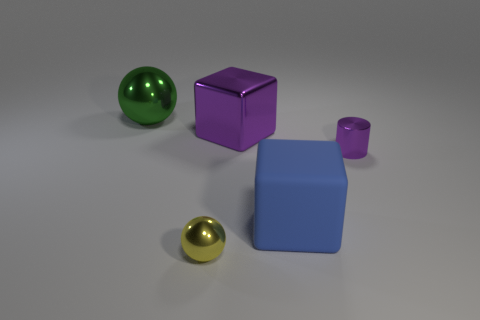What color is the other big thing that is the same shape as the yellow object?
Ensure brevity in your answer.  Green. What is the size of the metallic cylinder?
Offer a very short reply. Small. Is the number of shiny cubes behind the green ball less than the number of purple cylinders?
Your answer should be compact. Yes. Is the green ball made of the same material as the purple object to the right of the big metallic cube?
Your answer should be compact. Yes. Are there any blue objects behind the big cube that is behind the small metal object to the right of the yellow object?
Provide a short and direct response. No. Is there anything else that has the same size as the matte object?
Keep it short and to the point. Yes. There is a tiny ball that is the same material as the purple cube; what is its color?
Offer a terse response. Yellow. There is a metal object that is both right of the small yellow thing and to the left of the small purple cylinder; what is its size?
Your answer should be very brief. Large. Are there fewer balls that are behind the large green thing than big matte objects that are behind the cylinder?
Your answer should be very brief. No. Is the material of the small object that is left of the large purple cube the same as the block that is in front of the purple shiny cube?
Provide a succinct answer. No. 